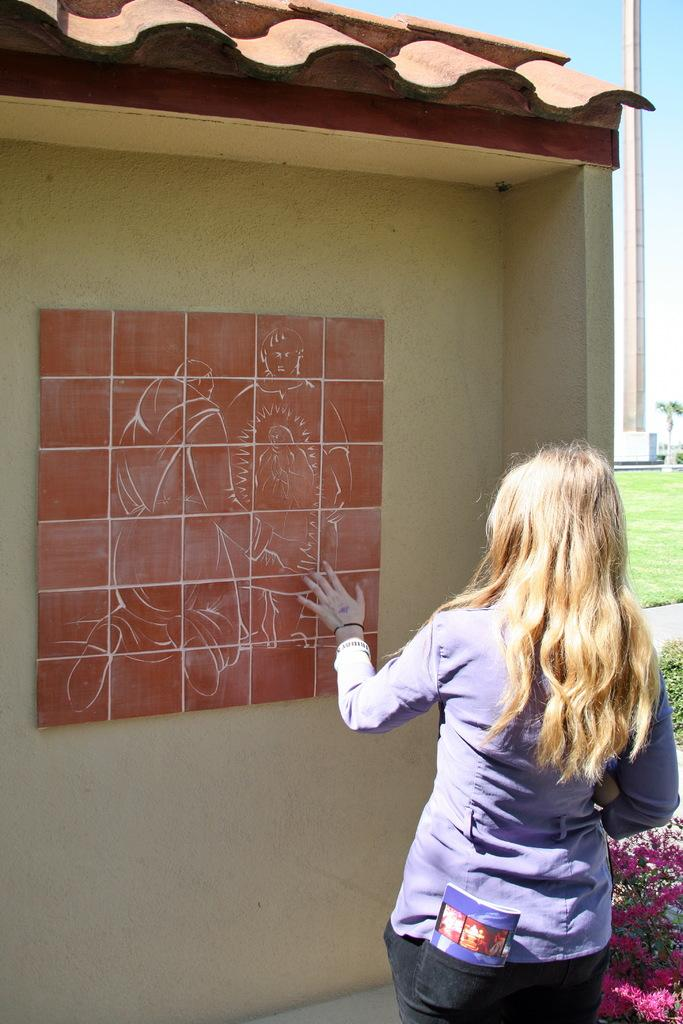What item is in her pocket in the image? There is a book in her pocket. What is she doing in the image? She is looking at a picture. What can be seen on the right side of the image? There is a pillar, a tree, grass, and plants with flowers on the right side of the image. What kind of trouble is her sister causing in the image? There is no sister present in the image, and therefore no trouble can be attributed to her. 